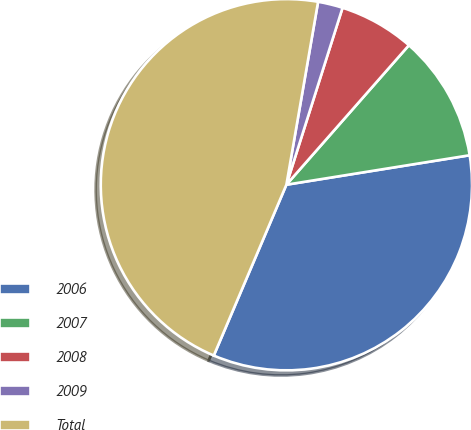Convert chart to OTSL. <chart><loc_0><loc_0><loc_500><loc_500><pie_chart><fcel>2006<fcel>2007<fcel>2008<fcel>2009<fcel>Total<nl><fcel>33.93%<fcel>10.99%<fcel>6.58%<fcel>2.16%<fcel>46.33%<nl></chart> 